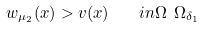Convert formula to latex. <formula><loc_0><loc_0><loc_500><loc_500>w _ { \mu _ { 2 } } ( x ) > v ( x ) \quad i n \Omega \ \Omega _ { \delta _ { 1 } }</formula> 